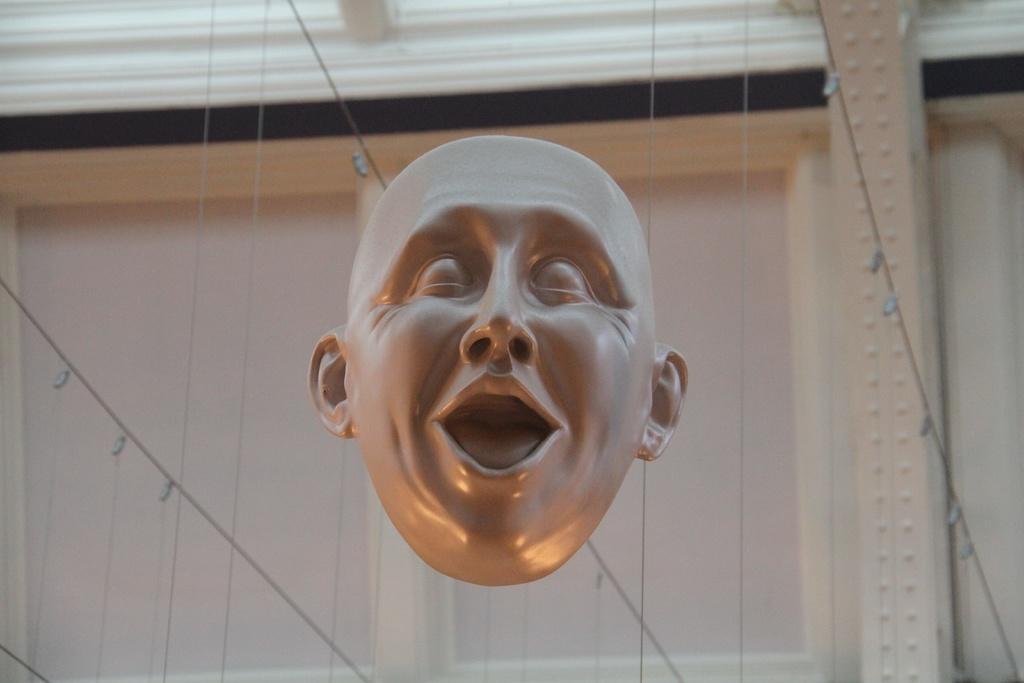Can you describe this image briefly? In this image there is a mask of a person's face, behind that there are strings and there is a window on the wall. 